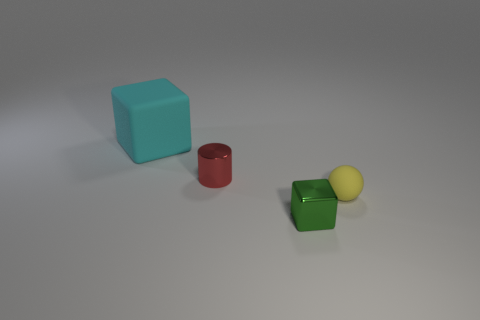Is there anything else that has the same size as the cyan cube?
Offer a terse response. No. What size is the sphere?
Give a very brief answer. Small. Is the number of big cyan rubber cubes in front of the tiny yellow object greater than the number of small yellow matte spheres that are left of the cyan matte thing?
Provide a short and direct response. No. There is a matte thing that is to the right of the big cyan rubber thing; how many tiny metallic things are in front of it?
Your answer should be compact. 1. Is the shape of the matte object right of the large object the same as  the red metal thing?
Provide a short and direct response. No. What is the material of the tiny thing that is the same shape as the large thing?
Provide a succinct answer. Metal. How many spheres are the same size as the red cylinder?
Give a very brief answer. 1. What is the color of the object that is behind the small green cube and in front of the red cylinder?
Your response must be concise. Yellow. Are there fewer tiny yellow things than large yellow metallic objects?
Make the answer very short. No. Does the cylinder have the same color as the block that is in front of the tiny sphere?
Offer a very short reply. No. 